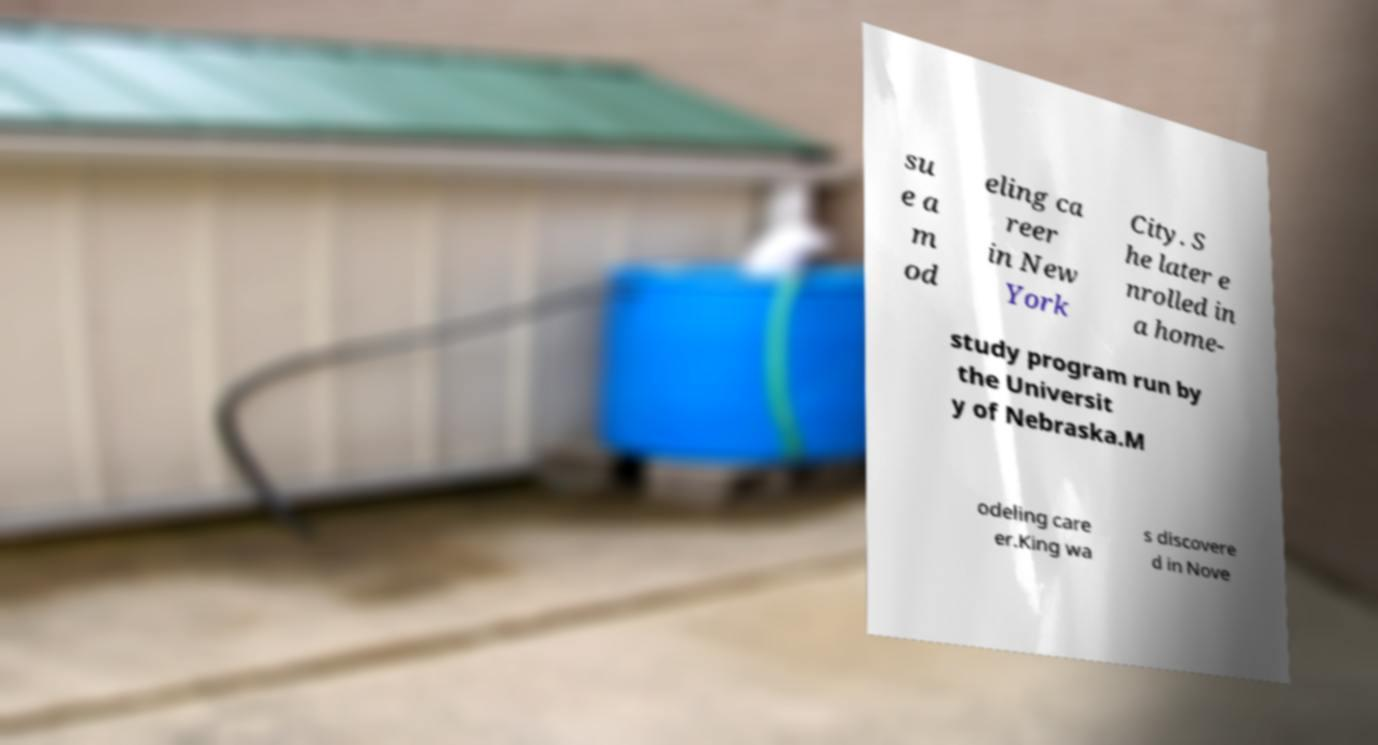Please read and relay the text visible in this image. What does it say? su e a m od eling ca reer in New York City. S he later e nrolled in a home- study program run by the Universit y of Nebraska.M odeling care er.King wa s discovere d in Nove 